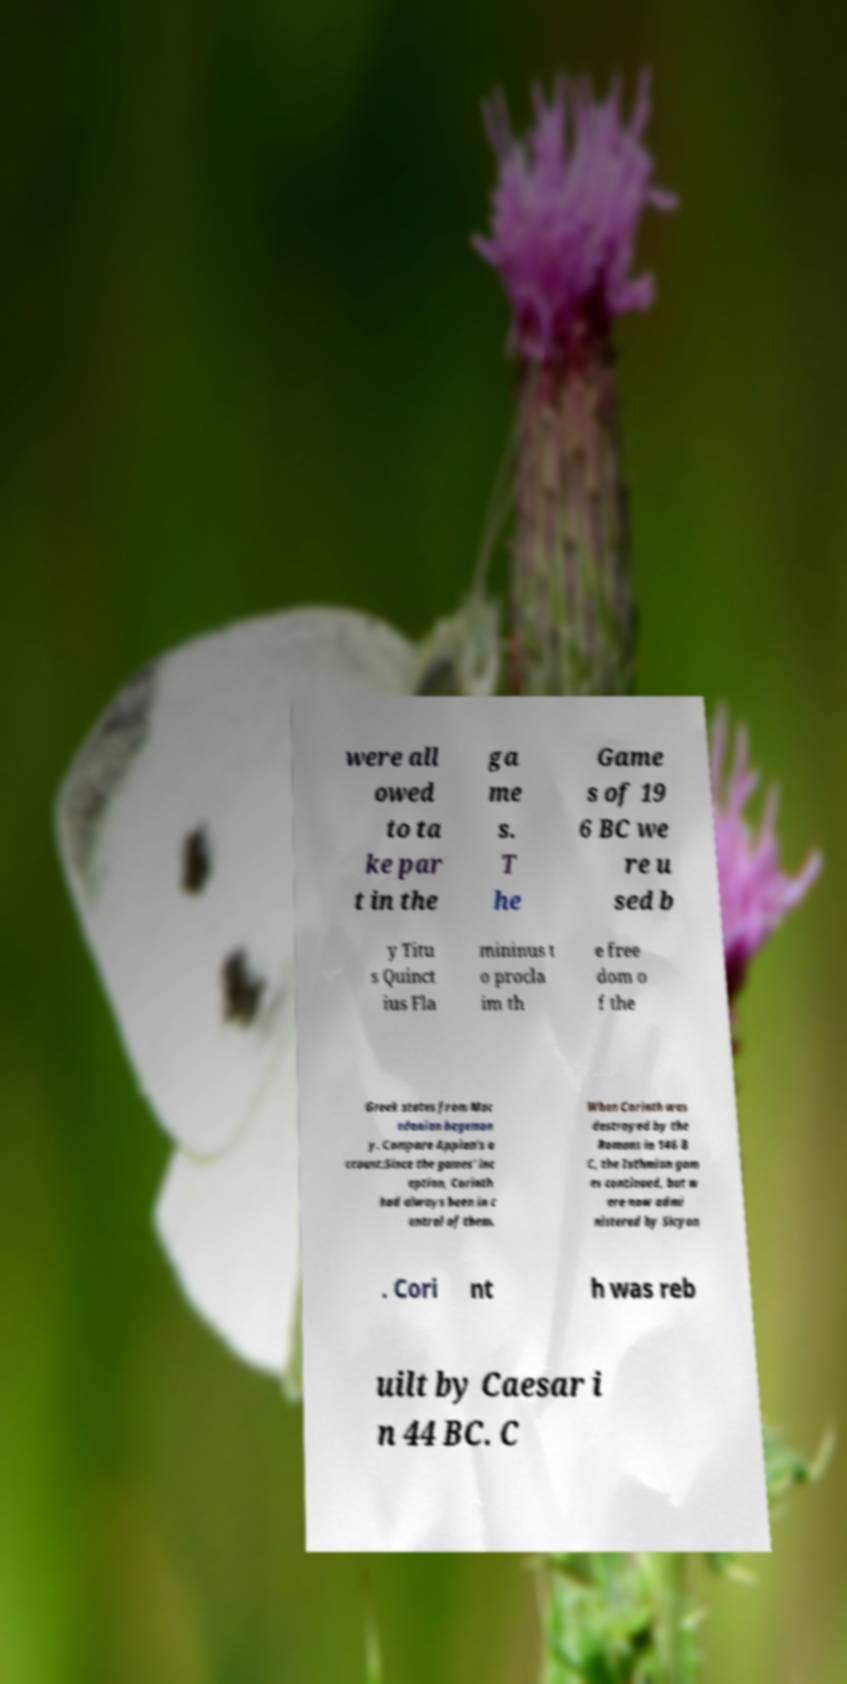Can you accurately transcribe the text from the provided image for me? were all owed to ta ke par t in the ga me s. T he Game s of 19 6 BC we re u sed b y Titu s Quinct ius Fla mininus t o procla im th e free dom o f the Greek states from Mac edonian hegemon y. Compare Appian's a ccount:Since the games' inc eption, Corinth had always been in c ontrol of them. When Corinth was destroyed by the Romans in 146 B C, the Isthmian gam es continued, but w ere now admi nistered by Sicyon . Cori nt h was reb uilt by Caesar i n 44 BC. C 